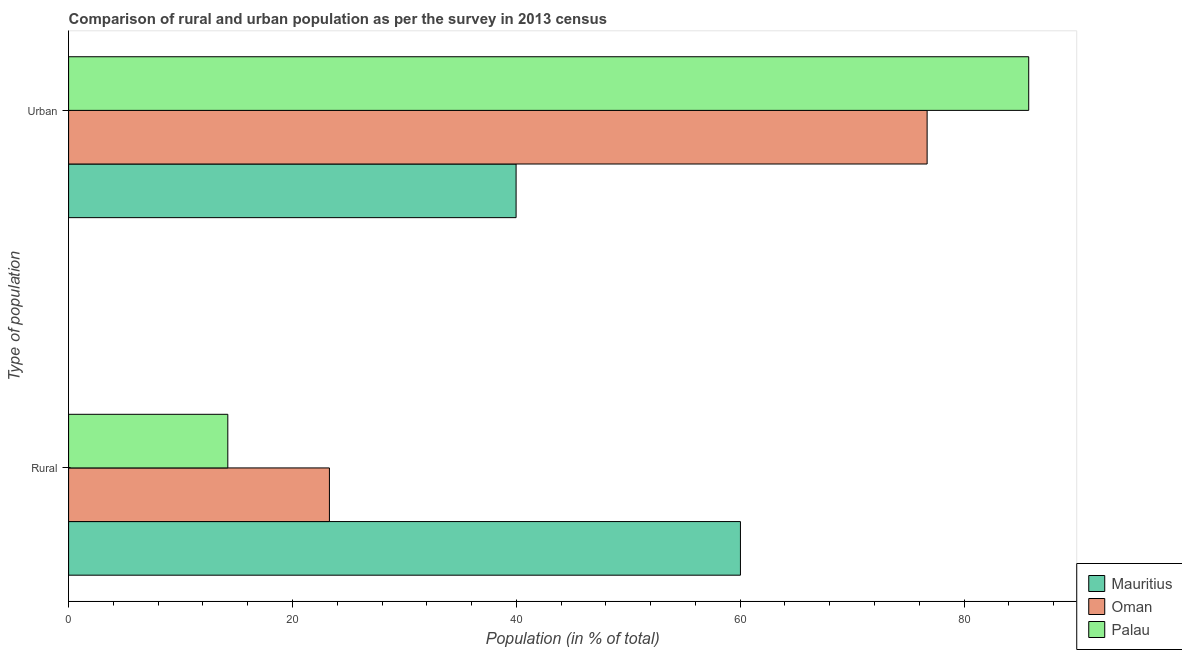How many different coloured bars are there?
Make the answer very short. 3. How many bars are there on the 2nd tick from the top?
Provide a succinct answer. 3. How many bars are there on the 1st tick from the bottom?
Make the answer very short. 3. What is the label of the 2nd group of bars from the top?
Provide a succinct answer. Rural. What is the urban population in Mauritius?
Offer a very short reply. 39.98. Across all countries, what is the maximum rural population?
Provide a succinct answer. 60.02. Across all countries, what is the minimum urban population?
Your answer should be compact. 39.98. In which country was the rural population maximum?
Keep it short and to the point. Mauritius. In which country was the rural population minimum?
Make the answer very short. Palau. What is the total urban population in the graph?
Your response must be concise. 202.45. What is the difference between the rural population in Palau and that in Oman?
Your answer should be compact. -9.08. What is the difference between the urban population in Palau and the rural population in Oman?
Make the answer very short. 62.48. What is the average urban population per country?
Ensure brevity in your answer.  67.48. What is the difference between the rural population and urban population in Oman?
Ensure brevity in your answer.  -53.4. In how many countries, is the rural population greater than 32 %?
Make the answer very short. 1. What is the ratio of the urban population in Palau to that in Oman?
Your answer should be compact. 1.12. What does the 3rd bar from the top in Urban represents?
Provide a short and direct response. Mauritius. What does the 1st bar from the bottom in Urban represents?
Offer a very short reply. Mauritius. How many bars are there?
Make the answer very short. 6. Are all the bars in the graph horizontal?
Ensure brevity in your answer.  Yes. How many countries are there in the graph?
Your answer should be compact. 3. What is the difference between two consecutive major ticks on the X-axis?
Give a very brief answer. 20. How many legend labels are there?
Offer a very short reply. 3. How are the legend labels stacked?
Ensure brevity in your answer.  Vertical. What is the title of the graph?
Offer a terse response. Comparison of rural and urban population as per the survey in 2013 census. Does "Spain" appear as one of the legend labels in the graph?
Give a very brief answer. No. What is the label or title of the X-axis?
Offer a very short reply. Population (in % of total). What is the label or title of the Y-axis?
Your answer should be very brief. Type of population. What is the Population (in % of total) of Mauritius in Rural?
Give a very brief answer. 60.02. What is the Population (in % of total) of Oman in Rural?
Keep it short and to the point. 23.3. What is the Population (in % of total) in Palau in Rural?
Give a very brief answer. 14.22. What is the Population (in % of total) in Mauritius in Urban?
Give a very brief answer. 39.98. What is the Population (in % of total) of Oman in Urban?
Provide a succinct answer. 76.7. What is the Population (in % of total) in Palau in Urban?
Offer a terse response. 85.78. Across all Type of population, what is the maximum Population (in % of total) in Mauritius?
Provide a short and direct response. 60.02. Across all Type of population, what is the maximum Population (in % of total) in Oman?
Your answer should be very brief. 76.7. Across all Type of population, what is the maximum Population (in % of total) of Palau?
Your response must be concise. 85.78. Across all Type of population, what is the minimum Population (in % of total) in Mauritius?
Offer a terse response. 39.98. Across all Type of population, what is the minimum Population (in % of total) of Oman?
Your response must be concise. 23.3. Across all Type of population, what is the minimum Population (in % of total) of Palau?
Your answer should be compact. 14.22. What is the total Population (in % of total) in Palau in the graph?
Your response must be concise. 100. What is the difference between the Population (in % of total) in Mauritius in Rural and that in Urban?
Provide a short and direct response. 20.04. What is the difference between the Population (in % of total) in Oman in Rural and that in Urban?
Make the answer very short. -53.4. What is the difference between the Population (in % of total) in Palau in Rural and that in Urban?
Your response must be concise. -71.55. What is the difference between the Population (in % of total) in Mauritius in Rural and the Population (in % of total) in Oman in Urban?
Offer a terse response. -16.68. What is the difference between the Population (in % of total) of Mauritius in Rural and the Population (in % of total) of Palau in Urban?
Your answer should be compact. -25.75. What is the difference between the Population (in % of total) in Oman in Rural and the Population (in % of total) in Palau in Urban?
Provide a succinct answer. -62.48. What is the difference between the Population (in % of total) of Mauritius and Population (in % of total) of Oman in Rural?
Your answer should be very brief. 36.72. What is the difference between the Population (in % of total) in Mauritius and Population (in % of total) in Palau in Rural?
Your answer should be very brief. 45.8. What is the difference between the Population (in % of total) of Oman and Population (in % of total) of Palau in Rural?
Your answer should be very brief. 9.08. What is the difference between the Population (in % of total) in Mauritius and Population (in % of total) in Oman in Urban?
Offer a terse response. -36.72. What is the difference between the Population (in % of total) of Mauritius and Population (in % of total) of Palau in Urban?
Offer a terse response. -45.8. What is the difference between the Population (in % of total) in Oman and Population (in % of total) in Palau in Urban?
Ensure brevity in your answer.  -9.08. What is the ratio of the Population (in % of total) of Mauritius in Rural to that in Urban?
Offer a very short reply. 1.5. What is the ratio of the Population (in % of total) of Oman in Rural to that in Urban?
Your response must be concise. 0.3. What is the ratio of the Population (in % of total) in Palau in Rural to that in Urban?
Your answer should be very brief. 0.17. What is the difference between the highest and the second highest Population (in % of total) in Mauritius?
Ensure brevity in your answer.  20.04. What is the difference between the highest and the second highest Population (in % of total) in Oman?
Provide a short and direct response. 53.4. What is the difference between the highest and the second highest Population (in % of total) in Palau?
Make the answer very short. 71.55. What is the difference between the highest and the lowest Population (in % of total) in Mauritius?
Ensure brevity in your answer.  20.04. What is the difference between the highest and the lowest Population (in % of total) in Oman?
Provide a short and direct response. 53.4. What is the difference between the highest and the lowest Population (in % of total) in Palau?
Your answer should be compact. 71.55. 